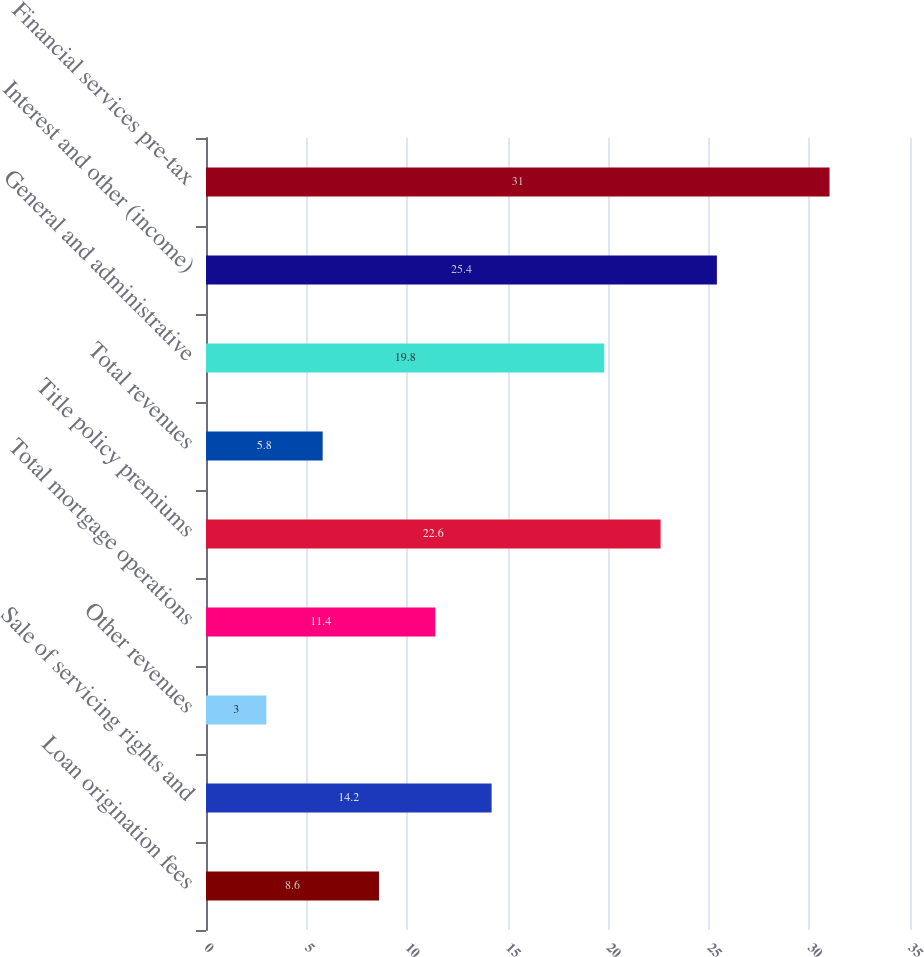Convert chart to OTSL. <chart><loc_0><loc_0><loc_500><loc_500><bar_chart><fcel>Loan origination fees<fcel>Sale of servicing rights and<fcel>Other revenues<fcel>Total mortgage operations<fcel>Title policy premiums<fcel>Total revenues<fcel>General and administrative<fcel>Interest and other (income)<fcel>Financial services pre-tax<nl><fcel>8.6<fcel>14.2<fcel>3<fcel>11.4<fcel>22.6<fcel>5.8<fcel>19.8<fcel>25.4<fcel>31<nl></chart> 